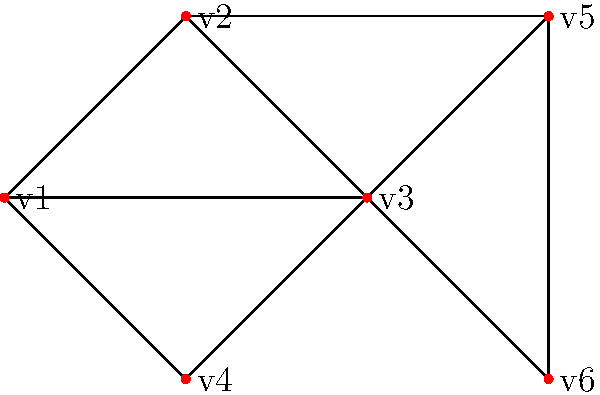Consider the undirected graph shown above. Calculate the betweenness centrality of vertex v3 and explain its significance in identifying influential nodes in this network. How does this measure compare to degree centrality for v3? To calculate the betweenness centrality of v3 and compare it to degree centrality, we'll follow these steps:

1. Betweenness Centrality Calculation:
   a) Identify all shortest paths between pairs of vertices.
   b) Count how many of these paths pass through v3.
   c) Calculate the betweenness centrality.

2. Degree Centrality Calculation:
   Count the number of edges connected to v3.

3. Comparison and significance analysis.

Step 1: Betweenness Centrality Calculation
a) Shortest paths (excluding those involving v3):
   v1-v2, v1-v4, v1-v5, v1-v6, v2-v4, v2-v5, v2-v6, v4-v5, v4-v6, v5-v6

b) Paths passing through v3:
   v1-v3-v2, v1-v3-v4, v1-v3-v5, v1-v3-v6, v4-v3-v2, v4-v3-v5, v4-v3-v6

c) Betweenness Centrality calculation:
   $BC(v3) = \sum_{s \neq v3 \neq t} \frac{\sigma_{st}(v3)}{\sigma_{st}}$
   Where $\sigma_{st}$ is the total number of shortest paths from s to t, and $\sigma_{st}(v3)$ is the number of those paths passing through v3.

   $BC(v3) = \frac{1}{1} + \frac{1}{1} + \frac{1}{2} + \frac{1}{2} + \frac{1}{1} + \frac{1}{2} + \frac{1}{2} = 4.5$

Step 2: Degree Centrality Calculation
v3 is connected to v1, v2, v4, v5, and v6.
Degree Centrality of v3 = 5

Step 3: Comparison and Significance
Betweenness Centrality (BC) of v3 is relatively high (4.5), indicating that it plays a crucial role in connecting different parts of the network. This suggests that v3 is an influential node in terms of information flow or network connectivity.

Degree Centrality (DC) of v3 is also high (5), which is the maximum in this network. This indicates that v3 has direct connections to many other nodes.

The high values of both BC and DC for v3 suggest that it is a critical node in the network. Its high degree centrality shows it has many direct connections, while its high betweenness centrality indicates it serves as a bridge between different parts of the network.

In complex networks, nodes with high betweenness centrality often act as important mediators or bridges, controlling the flow of information or resources. They may not always have the highest degree, but they are crucial for network cohesion and information dissemination.
Answer: Betweenness Centrality of v3 = 4.5; Degree Centrality of v3 = 5. v3 is a critical node, acting as both a hub (high DC) and a bridge (high BC) in the network. 